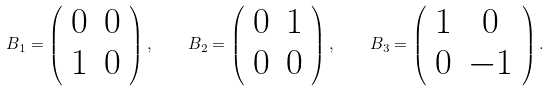<formula> <loc_0><loc_0><loc_500><loc_500>B _ { 1 } = \left ( \begin{array} { c c } 0 & 0 \\ 1 & 0 \\ \end{array} \right ) , \quad B _ { 2 } = \left ( \begin{array} { c c } 0 & 1 \\ 0 & 0 \\ \end{array} \right ) , \quad B _ { 3 } = \left ( \begin{array} { c c } 1 & 0 \\ 0 & - 1 \\ \end{array} \right ) .</formula> 